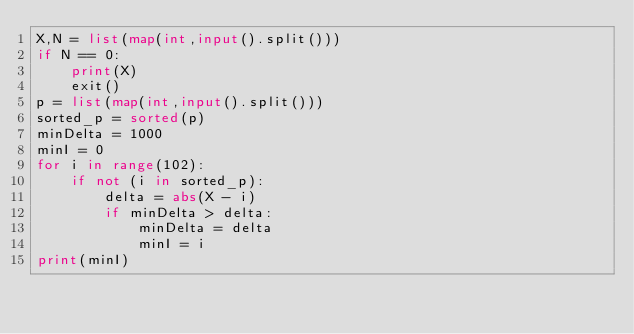<code> <loc_0><loc_0><loc_500><loc_500><_Python_>X,N = list(map(int,input().split()))
if N == 0:
    print(X)
    exit()
p = list(map(int,input().split()))
sorted_p = sorted(p)
minDelta = 1000
minI = 0
for i in range(102):
    if not (i in sorted_p):
        delta = abs(X - i)
        if minDelta > delta:
            minDelta = delta
            minI = i
print(minI)</code> 